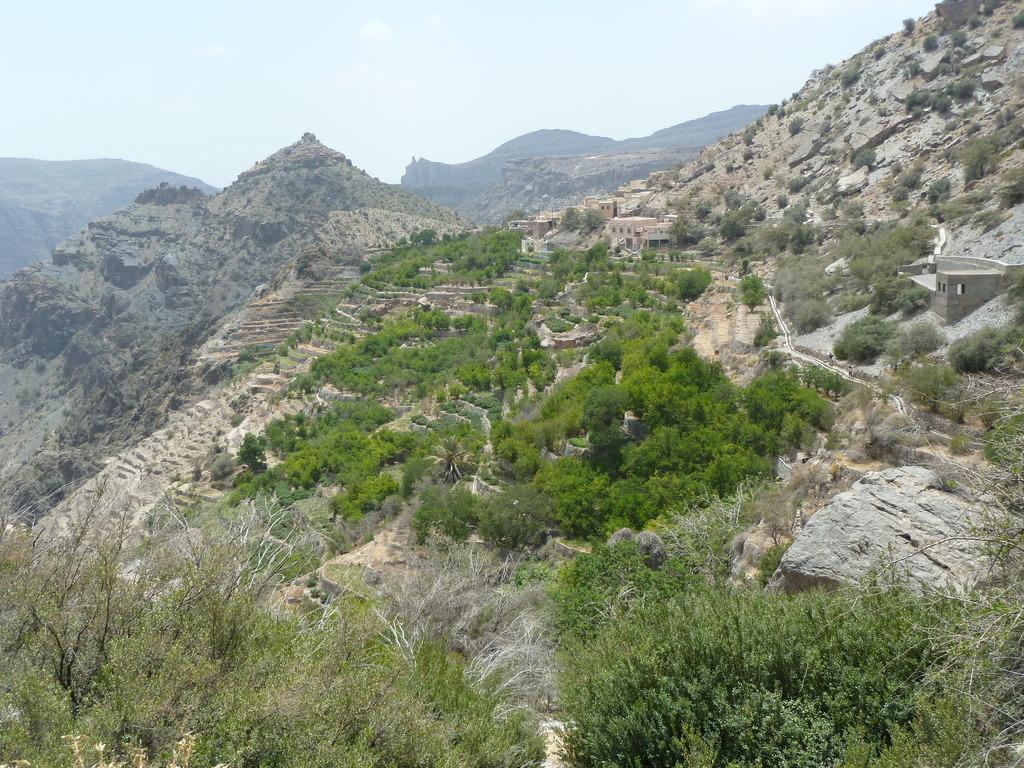Describe this image in one or two sentences. In the picture we can see trees, rocks, houses, and mountains. In the background there is sky. 